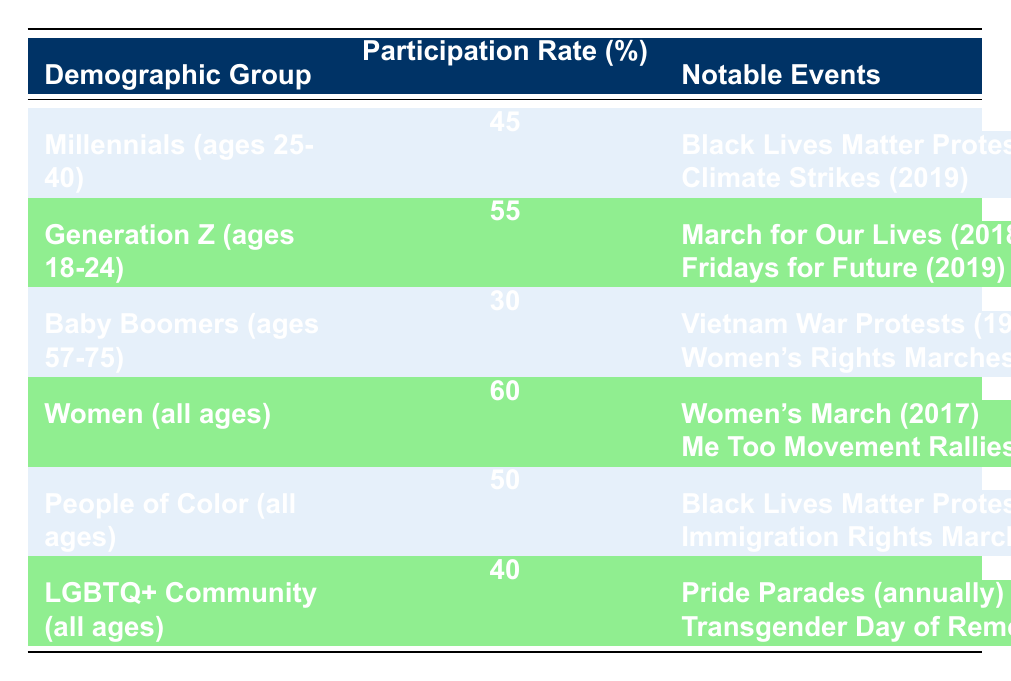What is the participation rate percentage for Women? The table lists the participation rate for Women as 60%. Therefore, the answer to this question can be directly retrieved from the table.
Answer: 60 Which demographic group has the lowest participation rate percentage? By examining the participation rates in the table, Baby Boomers (ages 57-75) have the lowest participation rate at 30%. This is the only value lower than all other groups listed.
Answer: Baby Boomers (ages 57-75) Is the participation rate for Generation Z (ages 18-24) higher than that for Millennials (ages 25-40)? The participation rate for Generation Z is 55% while the rate for Millennials is 45%. Since 55% is greater than 45%, this confirms that Generation Z has a higher rate.
Answer: Yes What is the average participation rate percentage for all groups listed in the table? First, sum the participation rates: 45 + 55 + 30 + 60 + 50 + 40 = 280. There are 6 groups, so divide the total by 6: 280 / 6 = approximately 46.67. Thus, the average participation rate is 46.67%.
Answer: 46.67 Do People of Color (all ages) have a higher participation rate than the LGBTQ+ Community (all ages)? The participation rate for People of Color is 50% and for the LGBTQ+ Community is 40%. Since 50% is greater than 40%, People of Color do have a higher participation rate.
Answer: Yes What notable events are associated with the participation of Women? The notable events listed for Women are the Women's March (2017) and Me Too Movement Rallies (2018). These events indicate significant moments where Women participated in protests.
Answer: Women's March (2017), Me Too Movement Rallies (2018) How much higher is the participation rate for Generation Z compared to the Baby Boomers? Generation Z's participation rate is 55% while that of Baby Boomers is 30%. The difference is calculated by subtracting 30 from 55, which gives 25. Therefore, Generation Z's rate is 25% higher than that of Baby Boomers.
Answer: 25 Is it true that the majority of the demographic groups have a participation rate above 50%? There are 6 groups and only 3 (Generation Z, Women, and People of Color) have rates above 50%. Therefore, a majority (more than half) do not have rates above 50%.
Answer: No What is the combined participation rate of Millennials and Baby Boomers? Adding the participation rates gives us 45 (Millennials) + 30 (Baby Boomers) = 75. Thus, the combined participation rate for these two groups is 75.
Answer: 75 